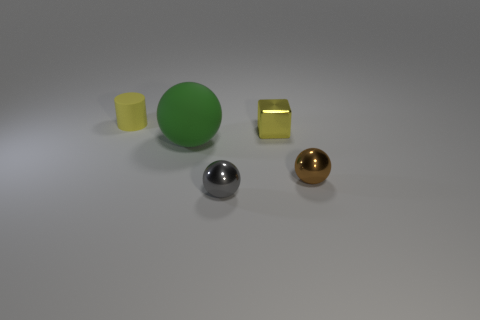What number of big objects are either metal things or green rubber spheres?
Provide a short and direct response. 1. How many other green objects have the same material as the large green object?
Your answer should be very brief. 0. What is the size of the object that is to the left of the large rubber object?
Your response must be concise. Small. What is the shape of the matte object in front of the rubber object to the left of the large object?
Offer a terse response. Sphere. How many brown balls are in front of the yellow object left of the small metallic object that is behind the big green object?
Offer a terse response. 1. Is the number of objects behind the tiny yellow matte cylinder less than the number of yellow cylinders?
Your response must be concise. Yes. Is there anything else that has the same shape as the tiny yellow matte thing?
Your response must be concise. No. There is a tiny yellow object that is in front of the tiny yellow rubber object; what is its shape?
Offer a terse response. Cube. What shape is the rubber object on the right side of the yellow object behind the yellow thing to the right of the matte cylinder?
Offer a very short reply. Sphere. What number of things are gray spheres or large blue rubber balls?
Provide a succinct answer. 1. 